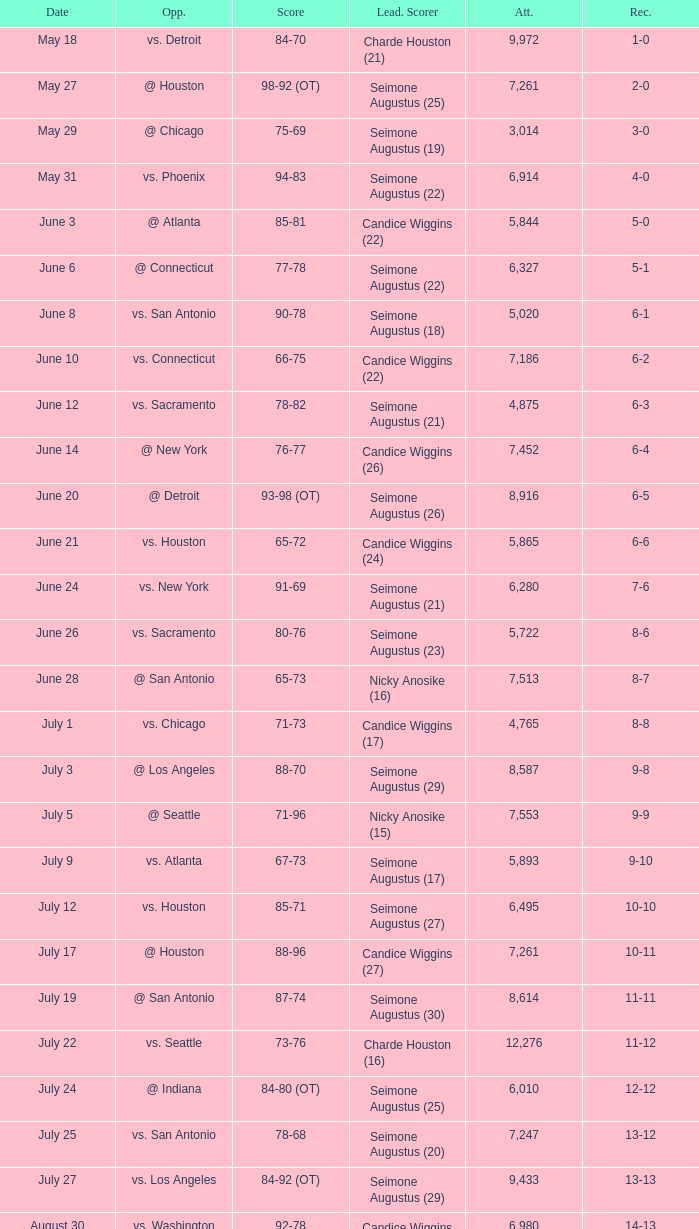Which Attendance has a Date of september 7? 7999.0. 